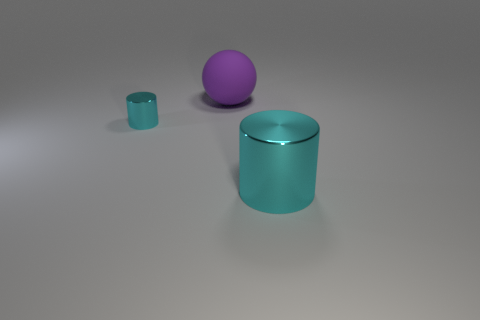Add 2 large balls. How many objects exist? 5 Subtract all cylinders. How many objects are left? 1 Add 2 blue rubber cubes. How many blue rubber cubes exist? 2 Subtract 0 gray balls. How many objects are left? 3 Subtract all cylinders. Subtract all matte balls. How many objects are left? 0 Add 2 large cylinders. How many large cylinders are left? 3 